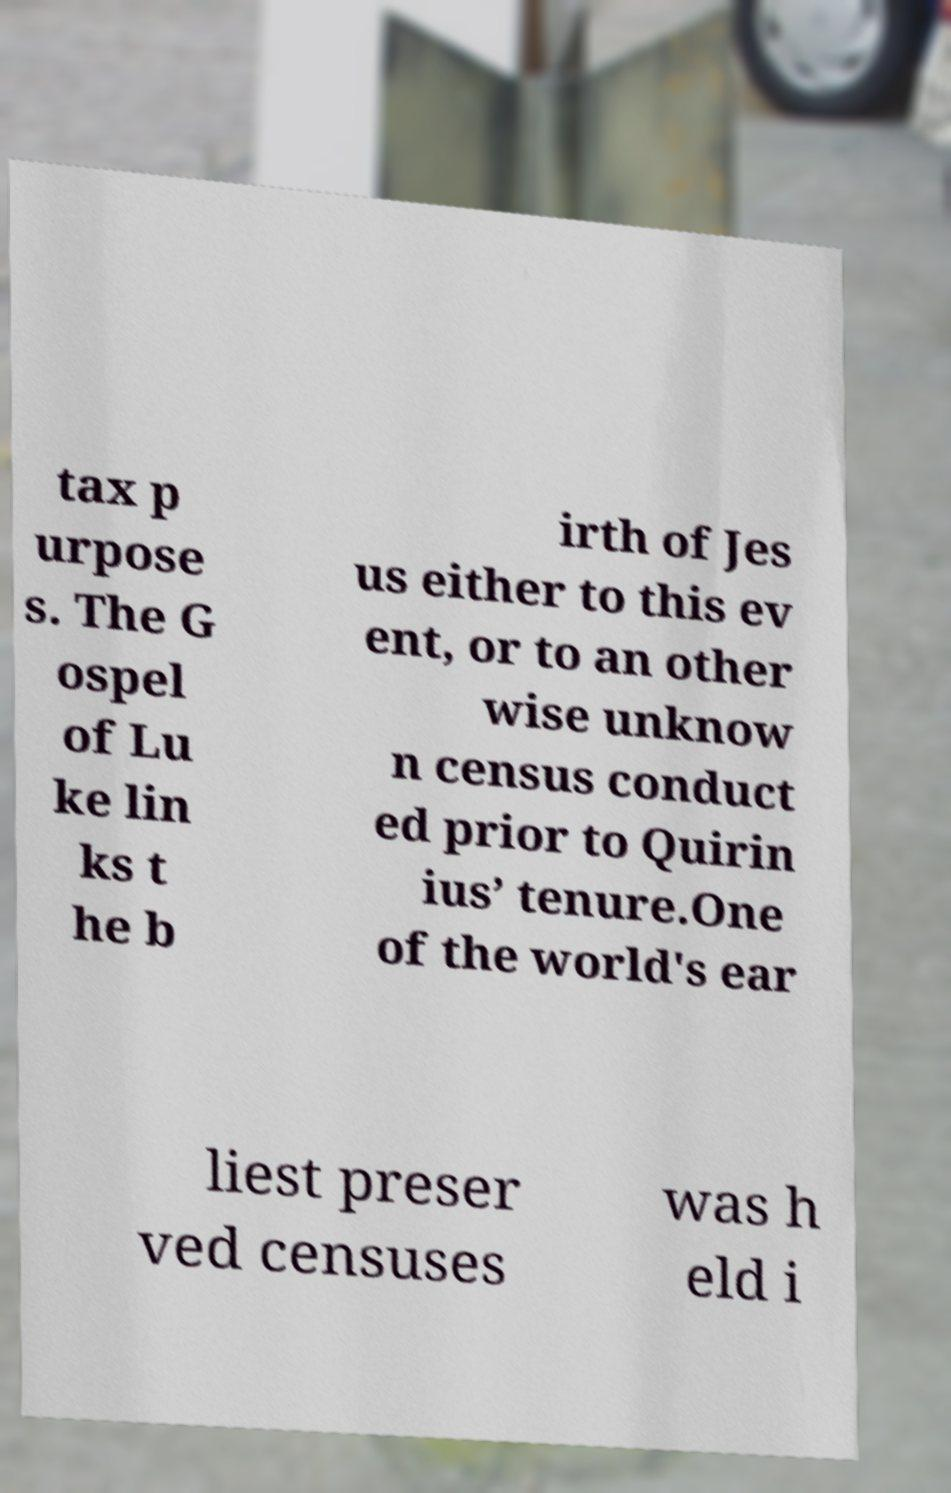Please identify and transcribe the text found in this image. tax p urpose s. The G ospel of Lu ke lin ks t he b irth of Jes us either to this ev ent, or to an other wise unknow n census conduct ed prior to Quirin ius’ tenure.One of the world's ear liest preser ved censuses was h eld i 